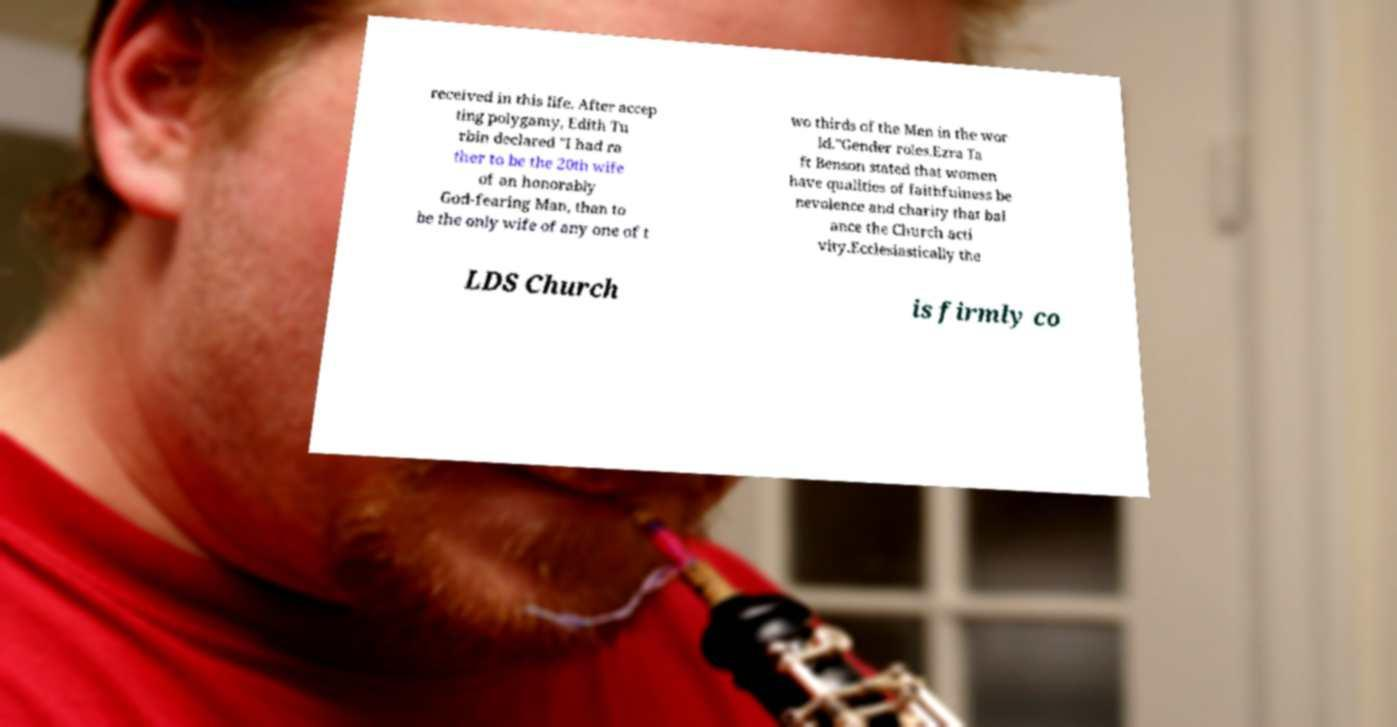For documentation purposes, I need the text within this image transcribed. Could you provide that? received in this life. After accep ting polygamy, Edith Tu rbin declared "I had ra ther to be the 20th wife of an honorably God-fearing Man, than to be the only wife of any one of t wo thirds of the Men in the wor ld."Gender roles.Ezra Ta ft Benson stated that women have qualities of faithfulness be nevolence and charity that bal ance the Church acti vity.Ecclesiastically the LDS Church is firmly co 